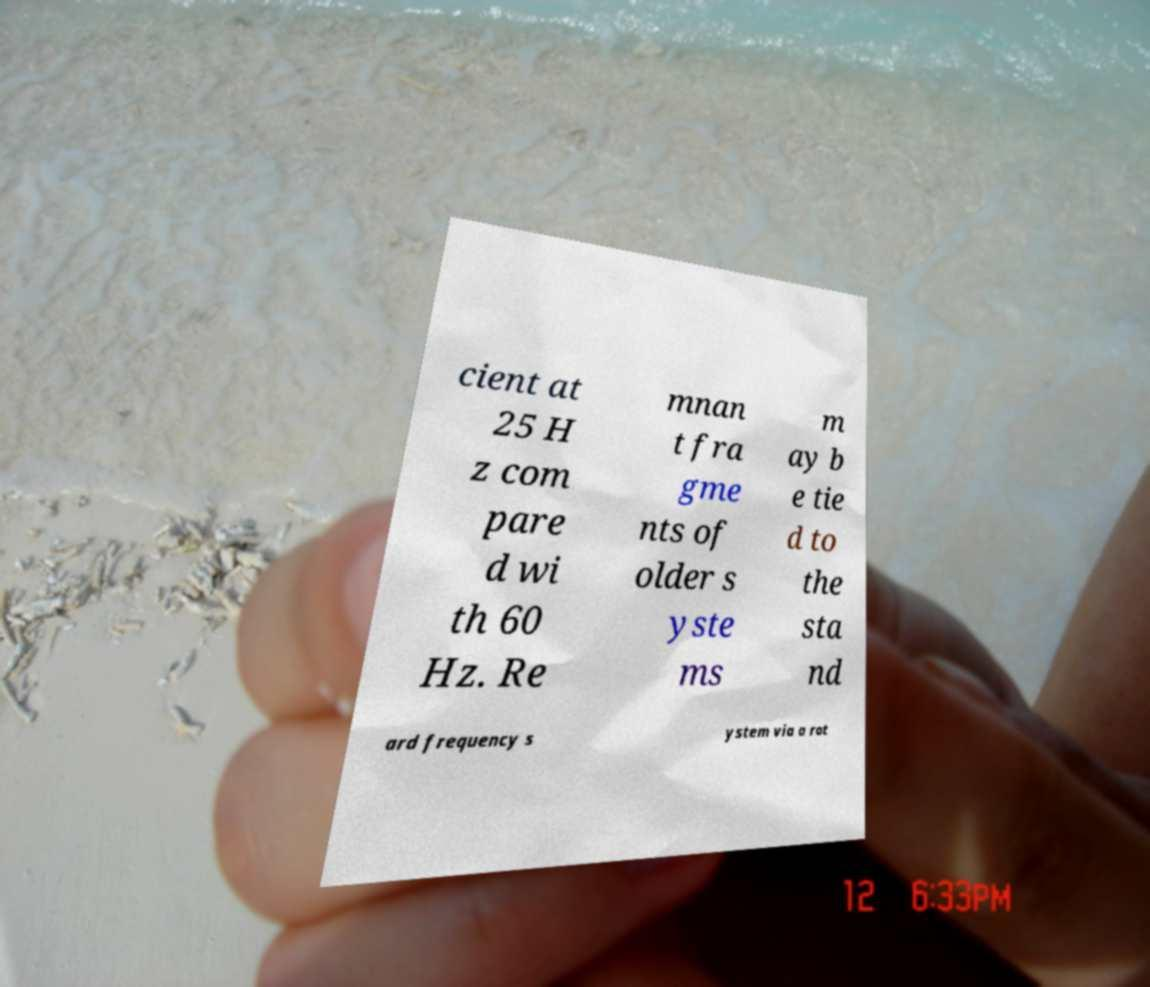Please read and relay the text visible in this image. What does it say? cient at 25 H z com pare d wi th 60 Hz. Re mnan t fra gme nts of older s yste ms m ay b e tie d to the sta nd ard frequency s ystem via a rot 